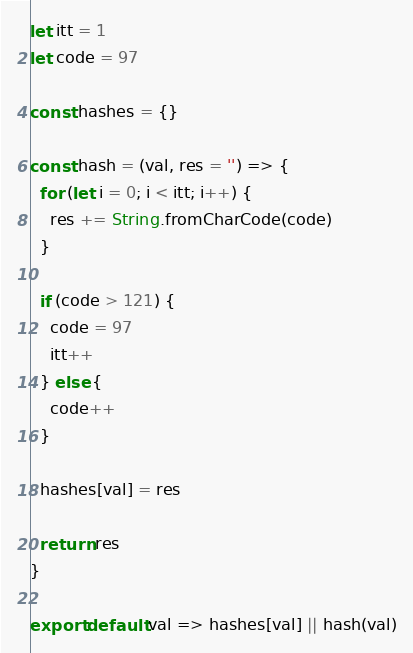Convert code to text. <code><loc_0><loc_0><loc_500><loc_500><_JavaScript_>let itt = 1
let code = 97

const hashes = {}

const hash = (val, res = '') => {
  for (let i = 0; i < itt; i++) {
    res += String.fromCharCode(code)
  }

  if (code > 121) {
    code = 97
    itt++
  } else {
    code++ 
  }

  hashes[val] = res

  return res
}

export default val => hashes[val] || hash(val)
</code> 